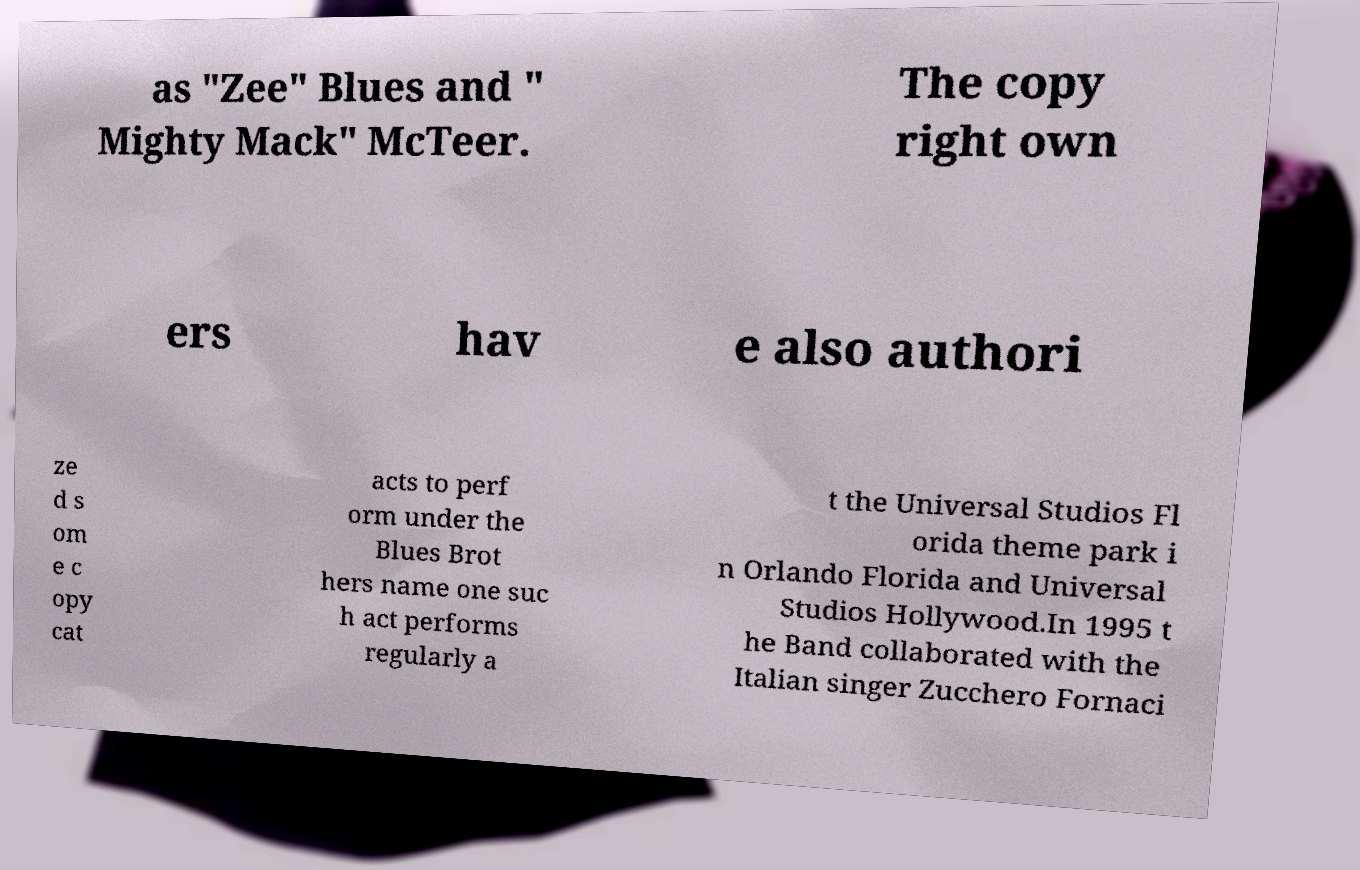Please read and relay the text visible in this image. What does it say? as "Zee" Blues and " Mighty Mack" McTeer. The copy right own ers hav e also authori ze d s om e c opy cat acts to perf orm under the Blues Brot hers name one suc h act performs regularly a t the Universal Studios Fl orida theme park i n Orlando Florida and Universal Studios Hollywood.In 1995 t he Band collaborated with the Italian singer Zucchero Fornaci 